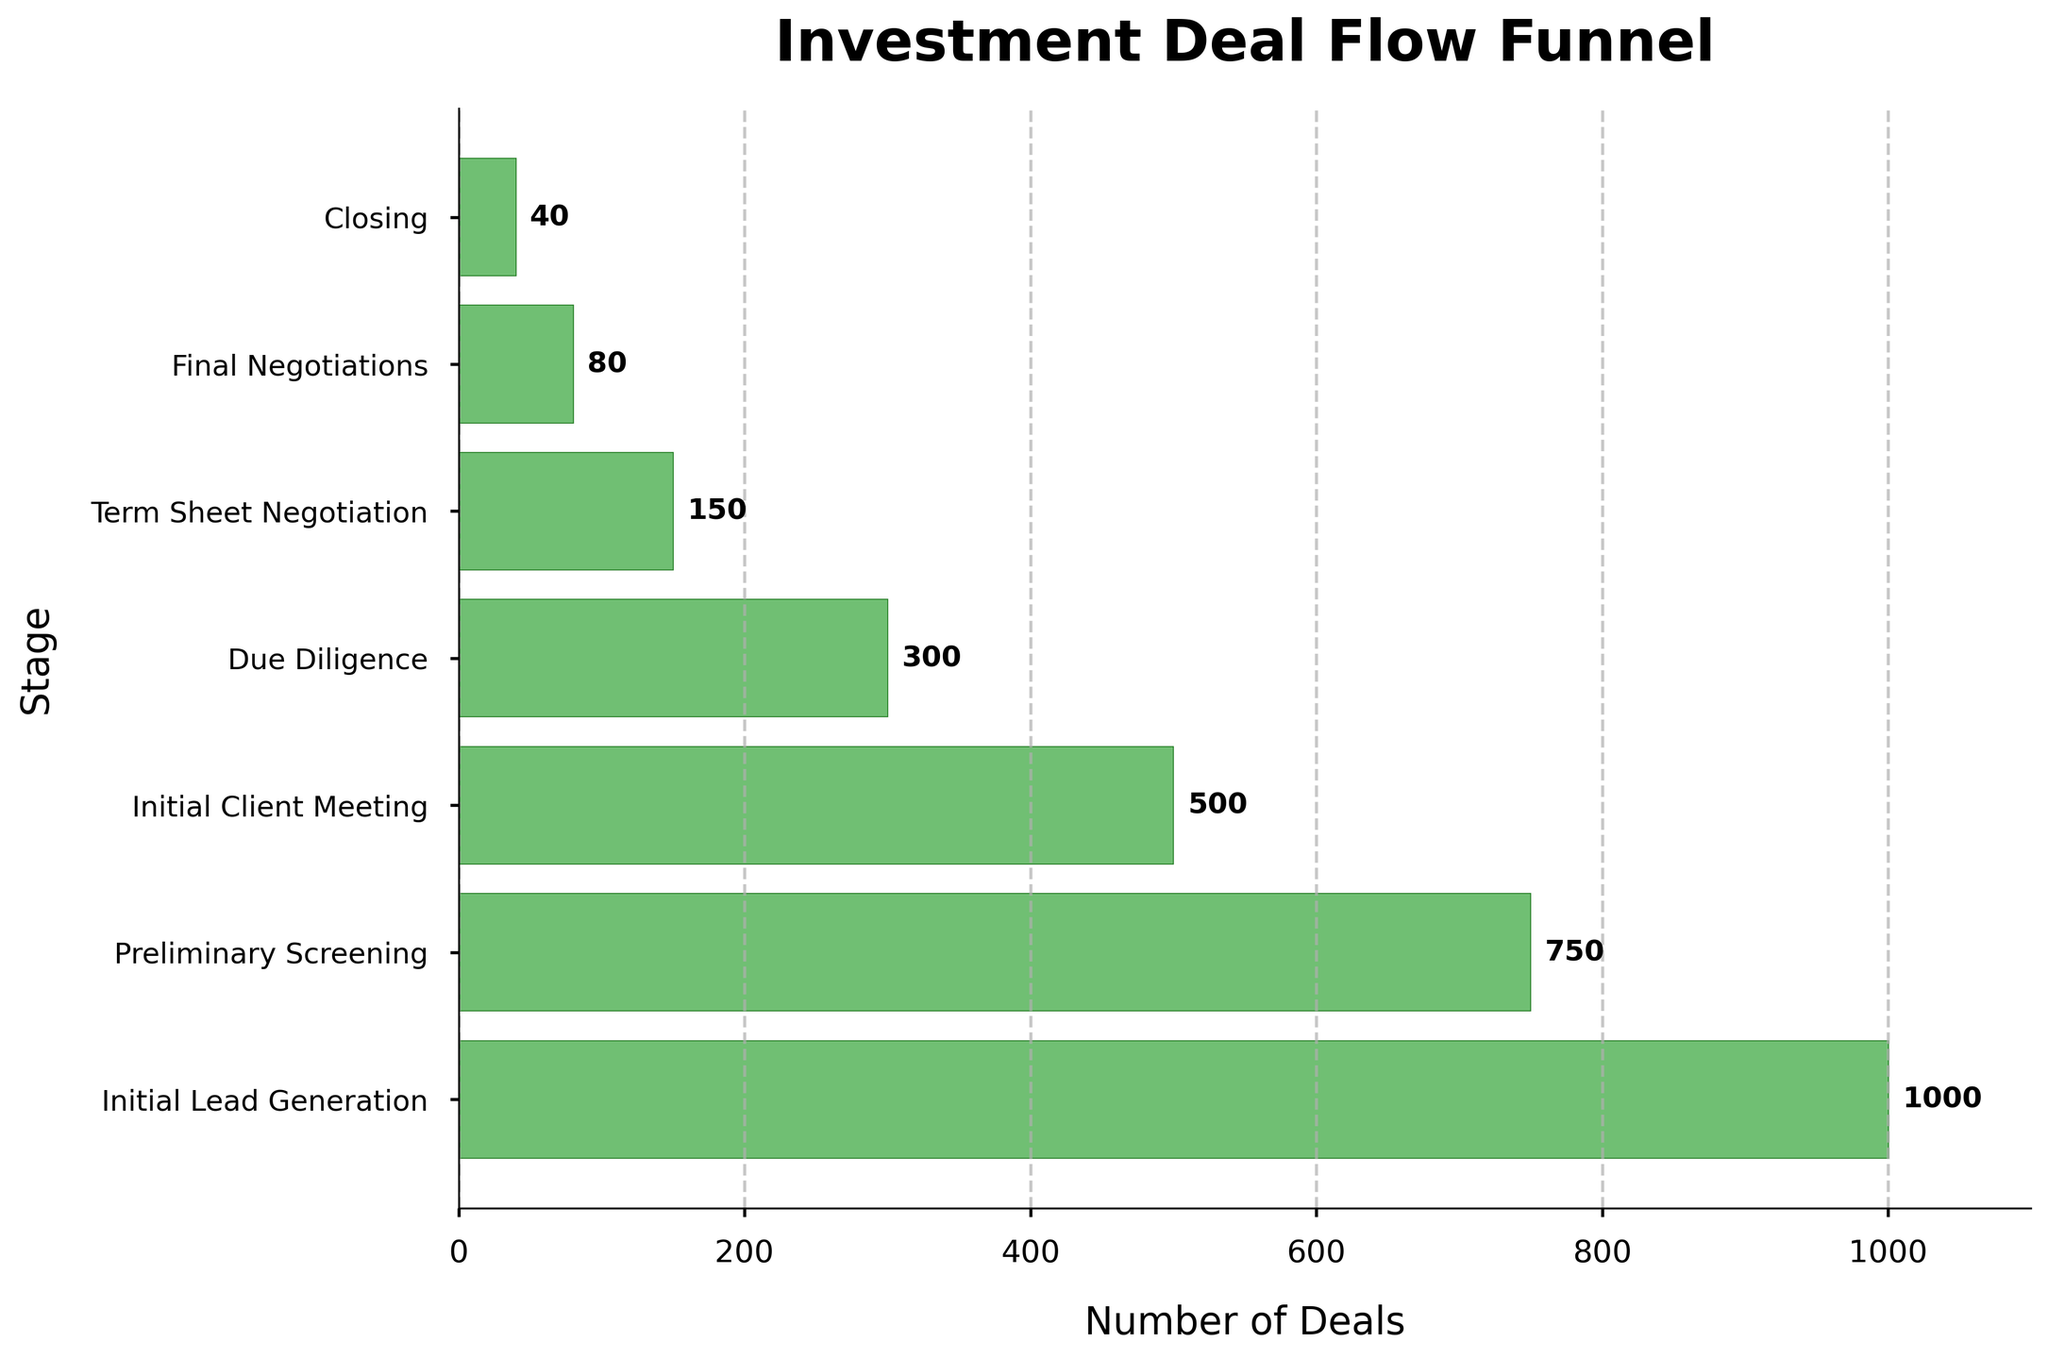What is the title of the funnel chart? The title is usually located at the top of the funnel chart. In this case, the title is "Investment Deal Flow Funnel" as indicated in the code.
Answer: Investment Deal Flow Funnel Which stage has the highest number of deals? To find the stage with the highest number of deals, look for the stage with the longest bar. The longest bar corresponds to "Initial Lead Generation."
Answer: Initial Lead Generation What is the relationship between the Initial Lead Generation stage and the Closing stage in terms of the number of deals? Compare the number of deals at both stages. Initial Lead Generation has 1000 deals, and Closing has 40. To find the ratio, divide 1000 by 40.
Answer: 1000:40 How many more deals are there in Term Sheet Negotiation compared to Final Negotiations? The number of deals in Term Sheet Negotiation is 150, and in Final Negotiations, it is 80. Subtract 80 from 150.
Answer: 70 What is the drop-off rate from Initial Lead Generation to Preliminary Screening? Initial Lead Generation has 1000 deals, while Preliminary Screening has 750. The drop-off rate is calculated as (1000 - 750) / 1000 * 100%.
Answer: 25% Calculate the average number of deals per stage. Sum the number of deals across all stages: 1000 + 750 + 500 + 300 + 150 + 80 + 40 = 2820. There are 7 stages, so divide 2820 by 7.
Answer: 402.86 (approx) Between which two adjacent stages is the largest drop-off in the number of deals observed? Calculate the drop-off between each pair of adjacent stages: 
- 1000 to 750 is 250 
- 750 to 500 is 250 
- 500 to 300 is 200 
- 300 to 150 is 150 
- 150 to 80 is 70 
- 80 to 40 is 40
The largest drop-off is between Initial Lead Generation and Preliminary Screening and between Preliminary Screening and Initial Client Meeting, each with a drop-off of 250 deals.
Answer: Initial Lead Generation to Preliminary Screening and Preliminary Screening to Initial Client Meeting What proportion of deals make it from Initial Lead Generation to the Closing stage? Calculate the proportion by dividing the number of deals in Closing (40) by Initial Lead Generation (1000) then multiply by 100 to get a percentage.
Answer: 4% How does the number of deals in Due Diligence compare to those in the Initial Client Meeting stage? Compare the number of deals directly. Due Diligence has 300 deals, and the Initial Client Meeting has 500 deals.
Answer: Due Diligence has 200 fewer deals than Initial Client Meeting 